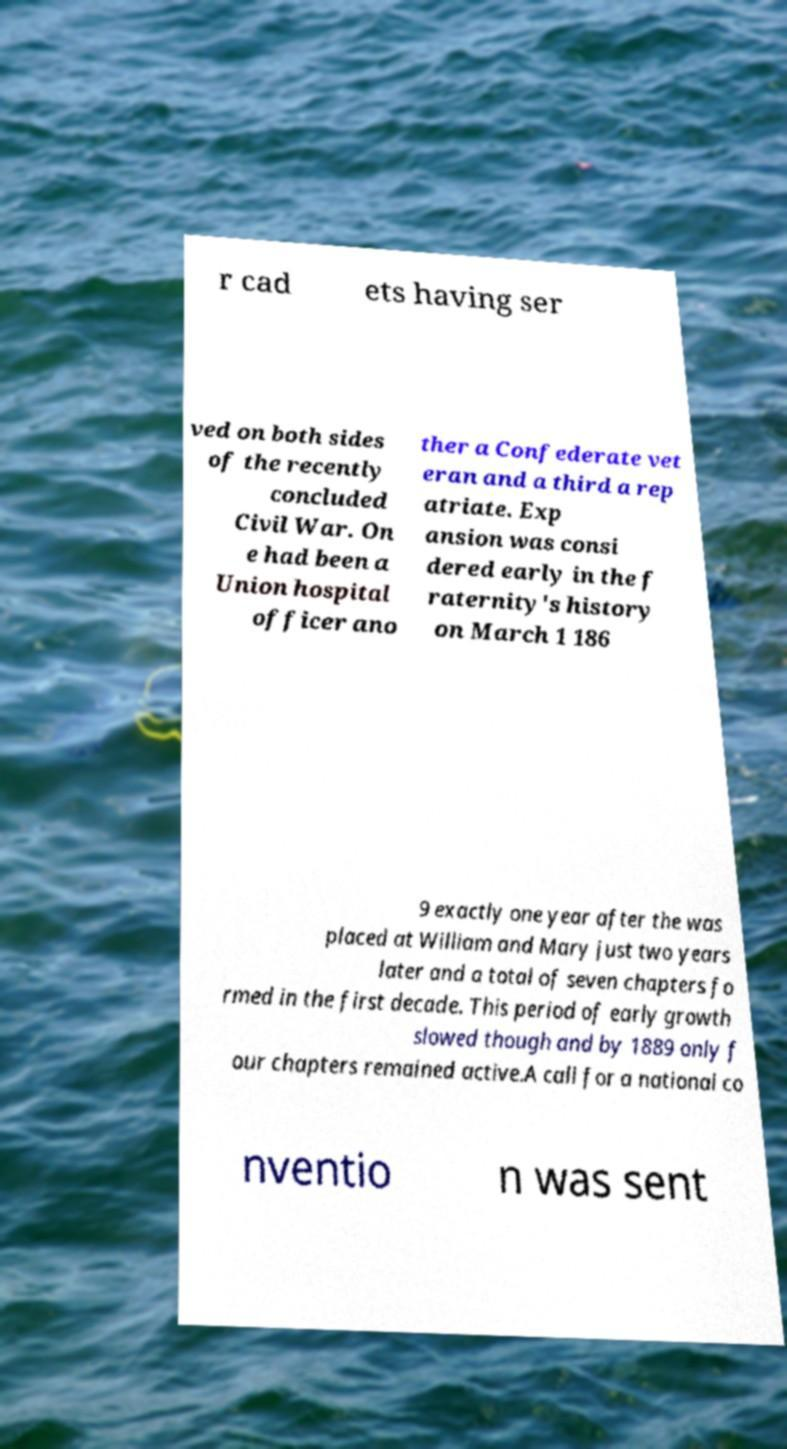For documentation purposes, I need the text within this image transcribed. Could you provide that? r cad ets having ser ved on both sides of the recently concluded Civil War. On e had been a Union hospital officer ano ther a Confederate vet eran and a third a rep atriate. Exp ansion was consi dered early in the f raternity's history on March 1 186 9 exactly one year after the was placed at William and Mary just two years later and a total of seven chapters fo rmed in the first decade. This period of early growth slowed though and by 1889 only f our chapters remained active.A call for a national co nventio n was sent 